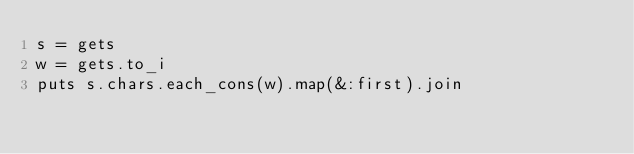Convert code to text. <code><loc_0><loc_0><loc_500><loc_500><_Ruby_>s = gets
w = gets.to_i
puts s.chars.each_cons(w).map(&:first).join</code> 